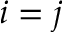<formula> <loc_0><loc_0><loc_500><loc_500>i = j</formula> 